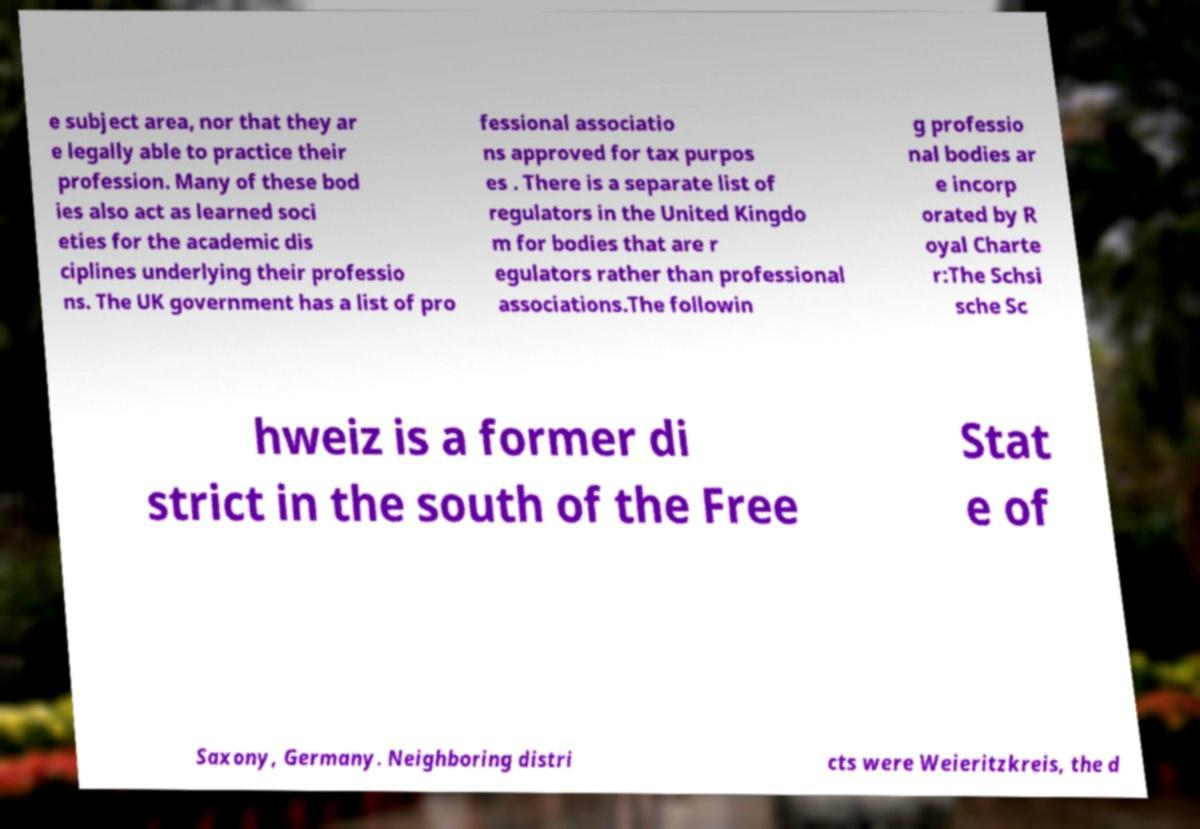Please read and relay the text visible in this image. What does it say? e subject area, nor that they ar e legally able to practice their profession. Many of these bod ies also act as learned soci eties for the academic dis ciplines underlying their professio ns. The UK government has a list of pro fessional associatio ns approved for tax purpos es . There is a separate list of regulators in the United Kingdo m for bodies that are r egulators rather than professional associations.The followin g professio nal bodies ar e incorp orated by R oyal Charte r:The Schsi sche Sc hweiz is a former di strict in the south of the Free Stat e of Saxony, Germany. Neighboring distri cts were Weieritzkreis, the d 